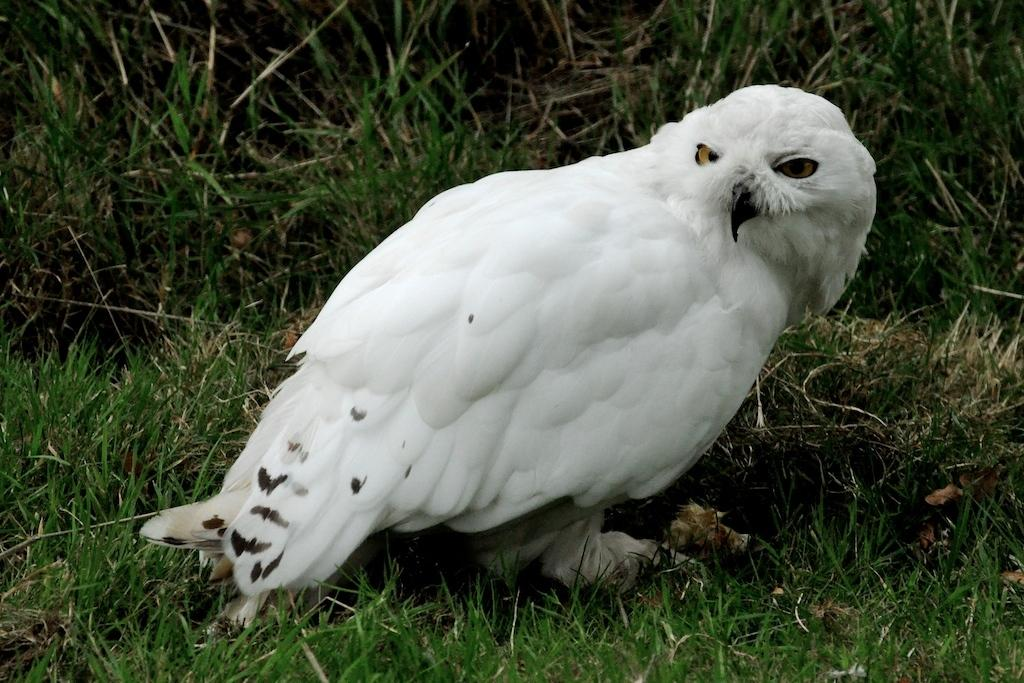What animal is in the center of the image? There is a white owl in the center of the image. What type of vegetation is visible at the bottom of the image? There is grass at the bottom of the image. What type of vegetation is visible at the top of the image? There is grass at the top of the image. What type of furniture is present in the image? There is no furniture present in the image; it features a white owl and grass. What is the owl's territory in the image? The image does not provide information about the owl's territory. 